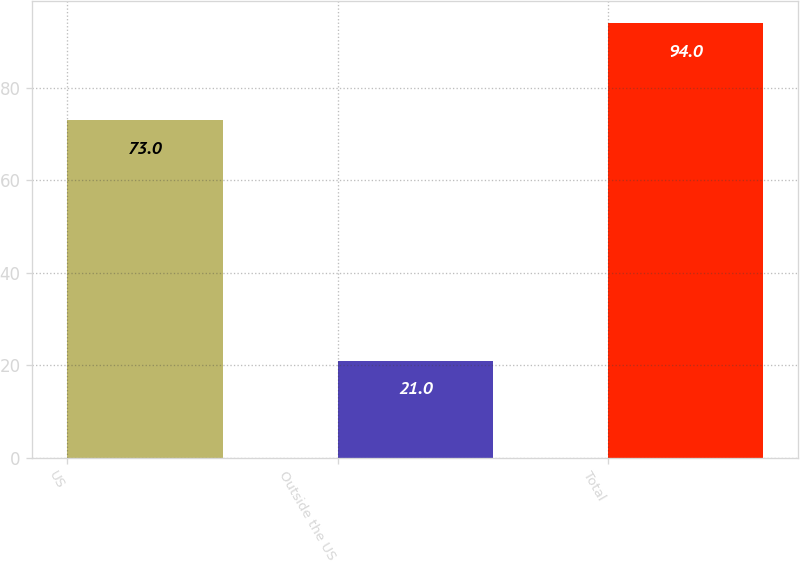<chart> <loc_0><loc_0><loc_500><loc_500><bar_chart><fcel>US<fcel>Outside the US<fcel>Total<nl><fcel>73<fcel>21<fcel>94<nl></chart> 